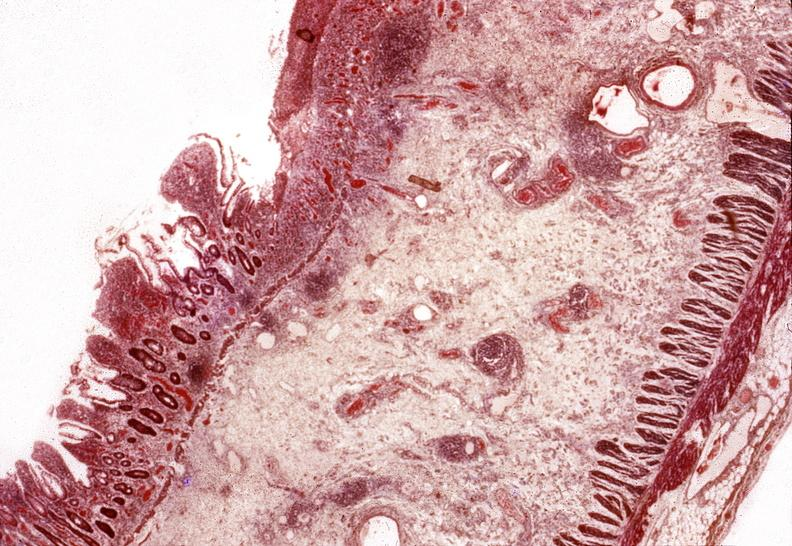s gastrointestinal present?
Answer the question using a single word or phrase. Yes 